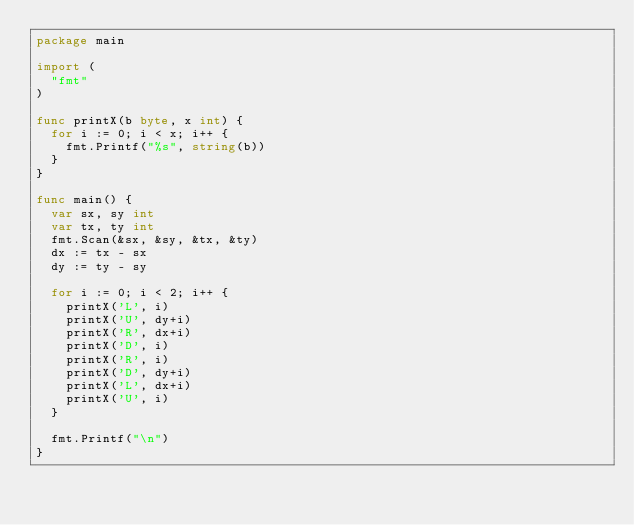Convert code to text. <code><loc_0><loc_0><loc_500><loc_500><_Go_>package main

import (
	"fmt"
)

func printX(b byte, x int) {
	for i := 0; i < x; i++ {
		fmt.Printf("%s", string(b))
	}
}

func main() {
	var sx, sy int
	var tx, ty int
	fmt.Scan(&sx, &sy, &tx, &ty)
	dx := tx - sx
	dy := ty - sy

	for i := 0; i < 2; i++ {
		printX('L', i)
		printX('U', dy+i)
		printX('R', dx+i)
		printX('D', i)
		printX('R', i)
		printX('D', dy+i)
		printX('L', dx+i)
		printX('U', i)
	}

	fmt.Printf("\n")
}
</code> 